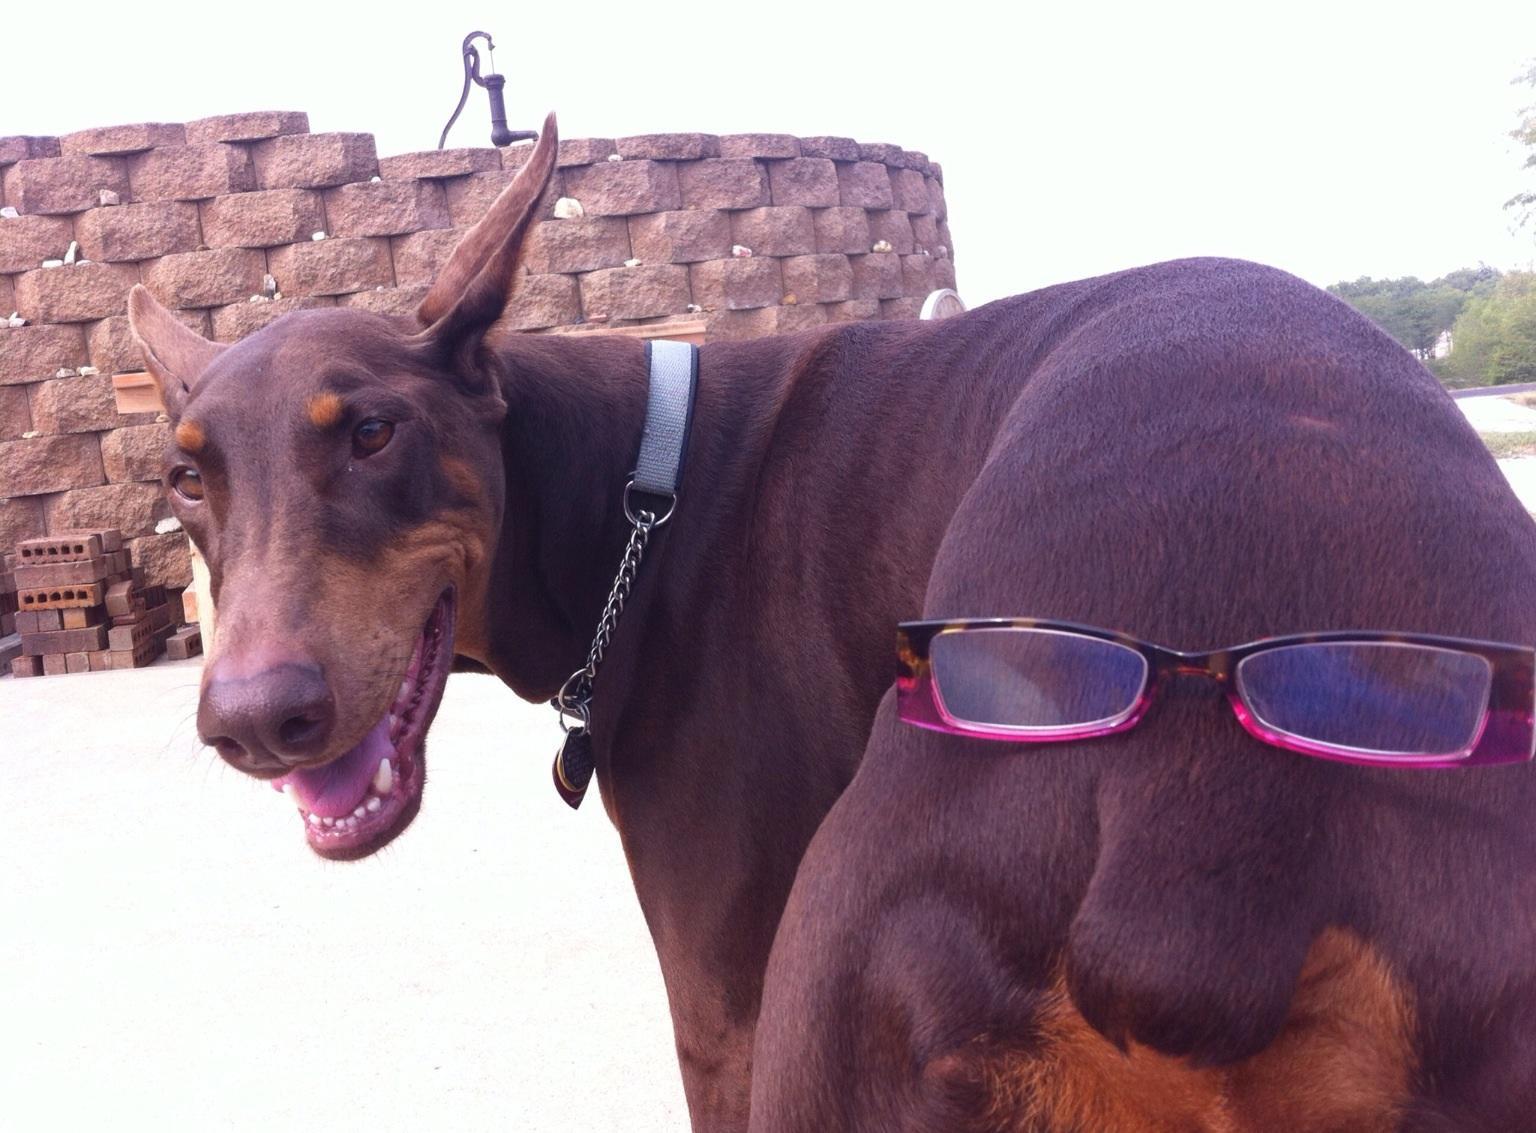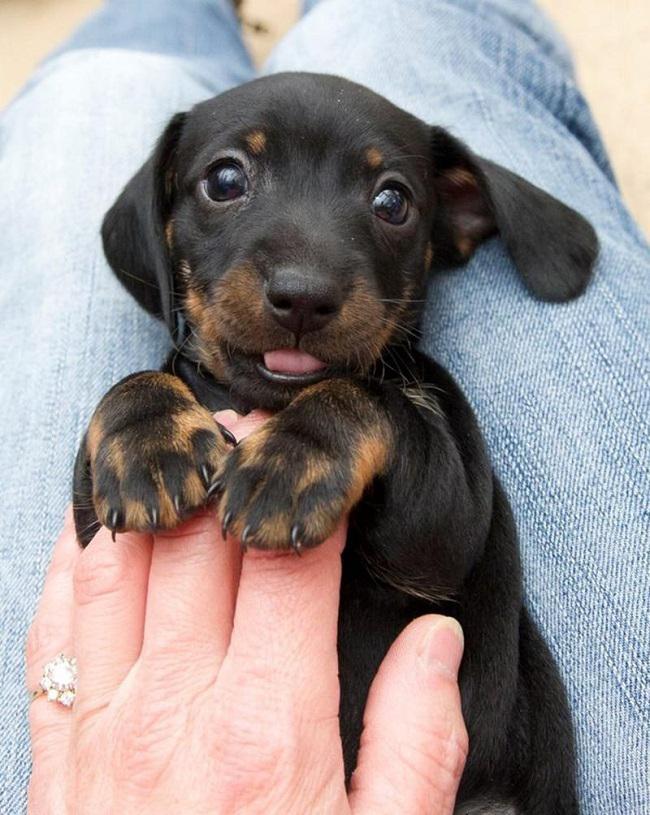The first image is the image on the left, the second image is the image on the right. Examine the images to the left and right. Is the description "The left and right image contains the same number of dogs, one being a puppy and the other being an adult." accurate? Answer yes or no. Yes. The first image is the image on the left, the second image is the image on the right. Assess this claim about the two images: "The left image contains one adult doberman with erect ears and its face straight ahead, and the right image includes at least one doberman reclining on something soft.". Correct or not? Answer yes or no. No. 